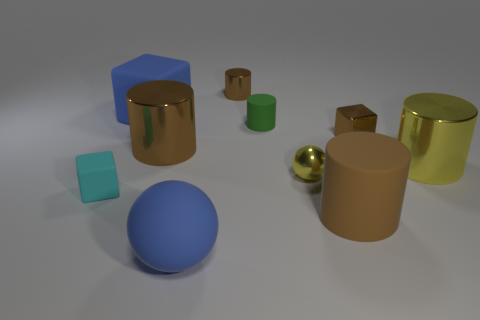Subtract all rubber cylinders. How many cylinders are left? 3 Subtract 5 cylinders. How many cylinders are left? 0 Subtract all blue blocks. Subtract all gray cylinders. How many blocks are left? 2 Subtract all gray balls. How many gray cylinders are left? 0 Subtract all tiny gray blocks. Subtract all blue things. How many objects are left? 8 Add 4 large blue matte balls. How many large blue matte balls are left? 5 Add 3 yellow metal things. How many yellow metal things exist? 5 Subtract all blue cubes. How many cubes are left? 2 Subtract 0 gray cylinders. How many objects are left? 10 Subtract all cubes. How many objects are left? 7 